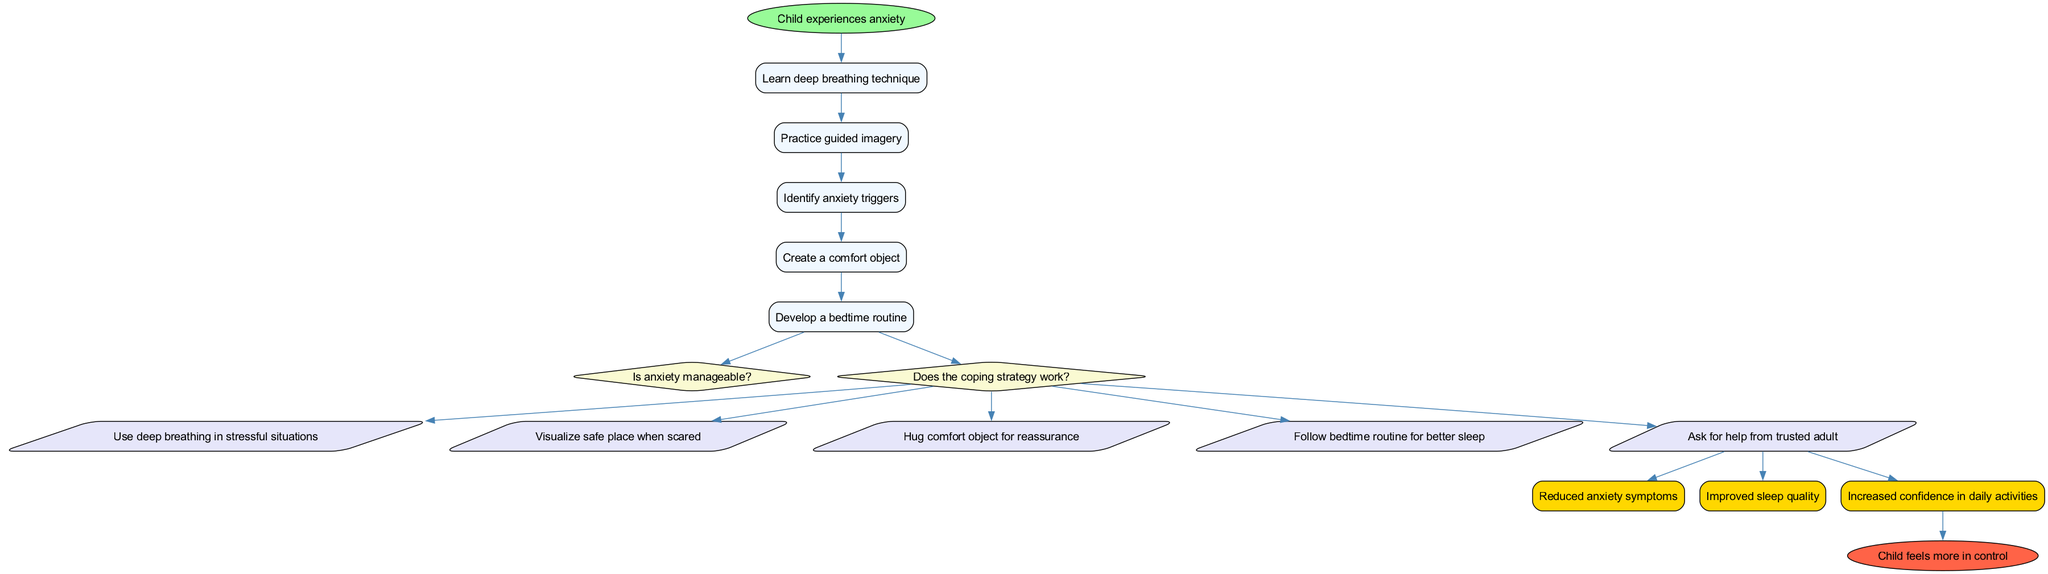What is the starting point of the diagram? The starting point is indicated by the "start" node, which states "Child experiences anxiety". This is the entry point of the flow chart.
Answer: Child experiences anxiety How many processes are listed in the diagram? The diagram lists five processes, which can be counted from the "processes" section: "Learn deep breathing technique", "Practice guided imagery", "Identify anxiety triggers", "Create a comfort object", and "Develop a bedtime routine".
Answer: 5 What is the last outcome before the end node? The last outcome listed is "Increased confidence in daily activities", which directly connects to the end node. This is the final result the child achieves before feeling more in control.
Answer: Increased confidence in daily activities What do the decision nodes assess? The two decision nodes assess: "Is anxiety manageable?" and "Does the coping strategy work?". These questions guide the flow of the diagram based on the child's situation and the effectiveness of their coping strategies.
Answer: Anxiety management and coping strategy effectiveness How many actions follow the second decision node? There are five actions that follow the second decision node. These actions stem from the decision made at "Does the coping strategy work?", which leads to several strategies the child might use.
Answer: 5 What is the connection between the last action and the outcomes? The last action, "Ask for help from trusted adult," connects directly to all the outcomes listed. This means that asking for help can result in one or more of the outcomes shown in the diagram.
Answer: Multiple outcomes Which process comes before identifying anxiety triggers? The process that comes before "Identify anxiety triggers" is "Practice guided imagery". This shows the sequential learning of strategies to cope with anxiety.
Answer: Practice guided imagery What shapes represent actions in the diagram? Actions in the diagram are represented by parallelogram shapes, which signify the strategies the child can take to cope with anxiety.
Answer: Parallelogram shapes What color is the end node? The end node is colored in a tomato red shade, indicated by the color designation of '#FF6347' in the diagram's attributes.
Answer: Tomato red 